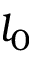<formula> <loc_0><loc_0><loc_500><loc_500>l _ { 0 }</formula> 